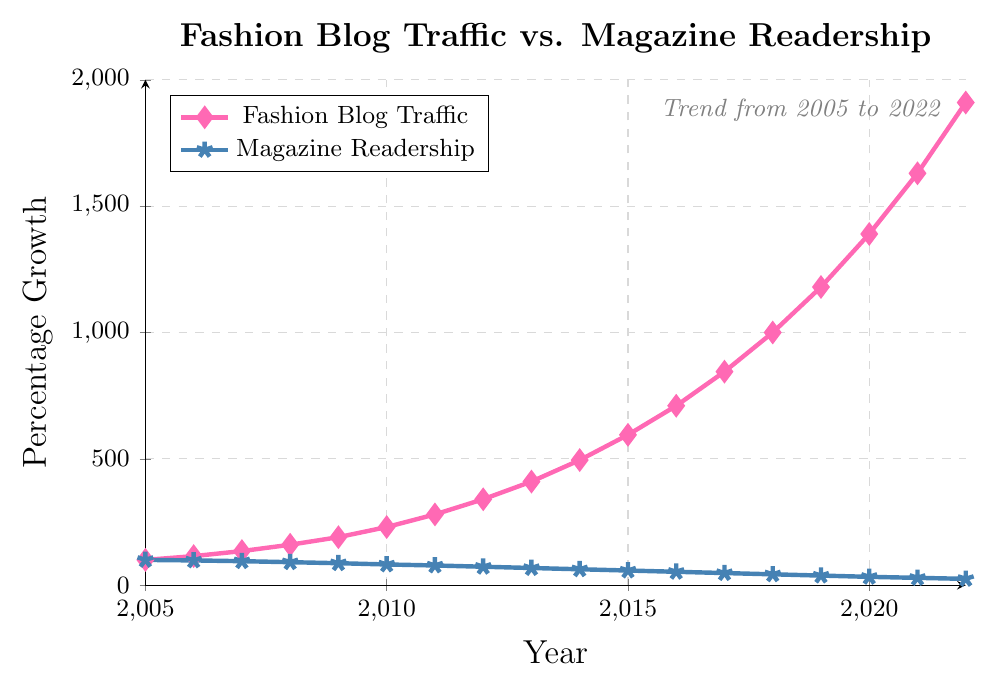What does the chart tell us about the trend of fashion blog traffic and magazine readership from 2005 to 2022? The chart shows that fashion blog traffic has increased significantly from 2005 to 2022, while traditional fashion magazine readership has steadily declined over the same period.
Answer: Increasing blog traffic, decreasing magazine readership By how much did fashion blog traffic increase in absolute terms from 2005 to 2022? The fashion blog traffic in 2005 was 100%, and it grew to 1910% in 2022. The increase in absolute terms is 1910% - 100% = 1810%.
Answer: 1810% In which year did fashion blog traffic surpass 1000%, and what was the corresponding magazine readership percentage that year? Fashion blog traffic surpassed 1000% in 2018, and the corresponding magazine readership percentage that year was 43%.
Answer: 2018, 43% How many years did it take for fashion blog traffic to increase from 500% to 1000%? Fashion blog traffic was approximately 495% in 2014 and surpassed 1000% in 2018. Therefore, it took 2018 - 2014 = 4 years.
Answer: 4 years When did traditional fashion magazine readership fall below 50%, and what was the percentage of fashion blog traffic that year? Traditional fashion magazine readership fell below 50% in 2017, and the percentage of fashion blog traffic that year was 845%.
Answer: 2017, 845% Compare the slope of the fashion blog traffic line to the slope of the magazine readership line. Which line is steeper and what does that indicate? The slope of the fashion blog traffic line is steeper than that of the magazine readership line. This indicates that fashion blog traffic is increasing at a much faster rate than the magazine readership is decreasing.
Answer: Fashion blog traffic line, faster increase What was the average percentage growth of fashion blog traffic and traditional magazine readership between 2010 and 2015? The percentage growth for fashion blog traffic in 2010 was 230%, and in 2015 it was 595%, so the average growth = (230% + 280% + 340% + 410% + 495% + 595%) / 6 = 391.67%. For magazine readership, it was 82% in 2010 and 58% in 2015, so the average growth = (82% + 78% + 73% + 68% + 63% + 58%) / 6 = 70.67%.
Answer: 391.67%, 70.67% What is the approximate difference in fashion blog traffic and magazine readership by 2022? In 2022, fashion blog traffic is 1910%, and magazine readership is 25%. The difference is 1910% - 25% = 1885%.
Answer: 1885% Identify the years when both fashion blog traffic and magazine readership were at their minimum and describe their values. Fashion blog traffic was at its minimum value in 2005 at 100%, and magazine readership was at its minimum value in 2022 at 25%.
Answer: 2005: 100% (blog), 2022: 25% (magazine) If the trends continue as shown in the chart beyond 2022, predict what might happen to magazine readership by 2025. If the declining trend of magazine readership continues, it is likely that the magazine readership might fall below 20% or even lower by 2025.
Answer: Below 20% 